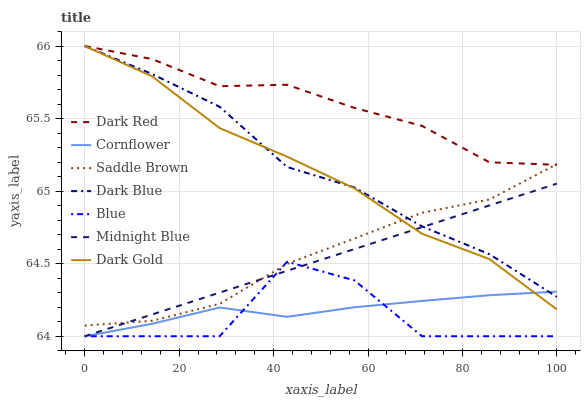Does Cornflower have the minimum area under the curve?
Answer yes or no. No. Does Cornflower have the maximum area under the curve?
Answer yes or no. No. Is Cornflower the smoothest?
Answer yes or no. No. Is Cornflower the roughest?
Answer yes or no. No. Does Dark Gold have the lowest value?
Answer yes or no. No. Does Midnight Blue have the highest value?
Answer yes or no. No. Is Midnight Blue less than Dark Red?
Answer yes or no. Yes. Is Saddle Brown greater than Cornflower?
Answer yes or no. Yes. Does Midnight Blue intersect Dark Red?
Answer yes or no. No. 